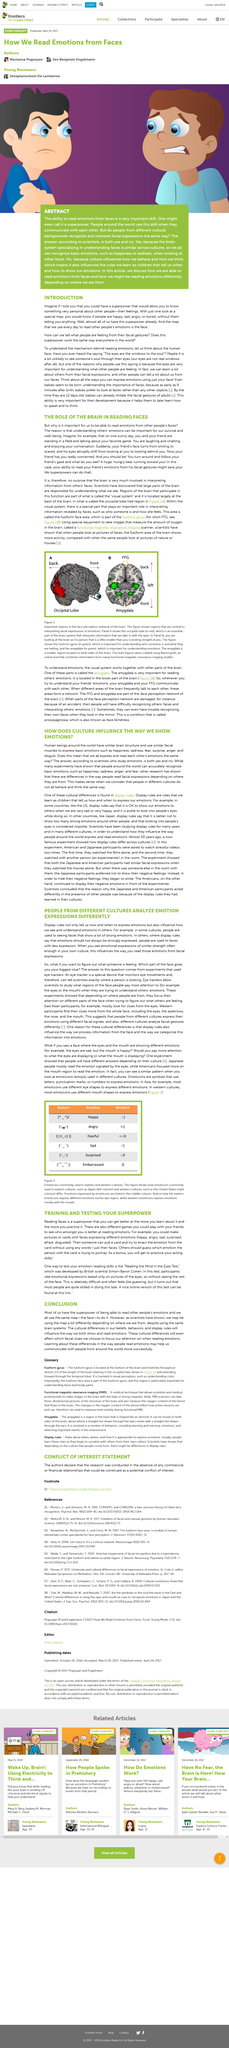Indicate a few pertinent items in this graphic. The title of this paragraph is Introduction. Some cultures are accustomed to seeing faces that frequently exhibit intense emotions. Playing the game will provide a bonus of practicing your acting skills. It is possible to determine the emotions of others by examining their facial expressions. It is possible to train and test one's superpower. 